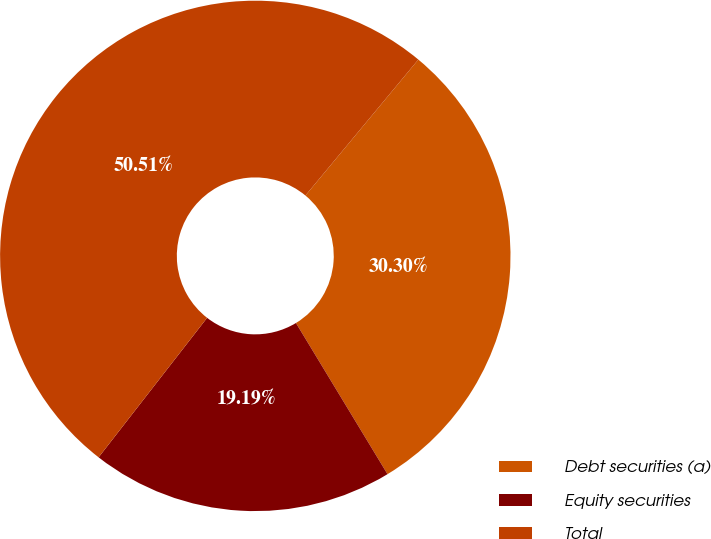<chart> <loc_0><loc_0><loc_500><loc_500><pie_chart><fcel>Debt securities (a)<fcel>Equity securities<fcel>Total<nl><fcel>30.3%<fcel>19.19%<fcel>50.51%<nl></chart> 